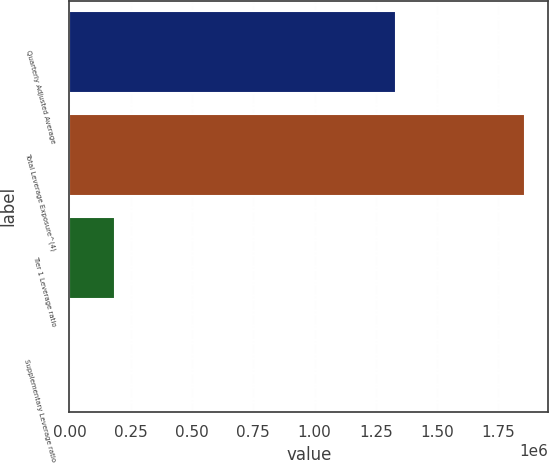Convert chart. <chart><loc_0><loc_0><loc_500><loc_500><bar_chart><fcel>Quarterly Adjusted Average<fcel>Total Leverage Exposure^(4)<fcel>Tier 1 Leverage ratio<fcel>Supplementary Leverage ratio<nl><fcel>1.33298e+06<fcel>1.85921e+06<fcel>185927<fcel>6.79<nl></chart> 